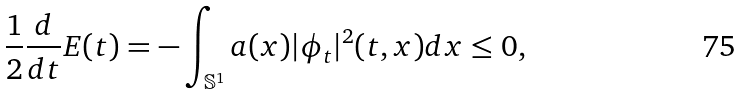<formula> <loc_0><loc_0><loc_500><loc_500>\frac { 1 } { 2 } \frac { d } { d t } E ( t ) = - \int _ { \mathbb { S } ^ { 1 } } a ( x ) | \phi _ { t } | ^ { 2 } ( t , x ) d x \leq 0 ,</formula> 